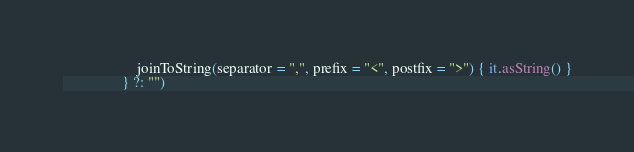<code> <loc_0><loc_0><loc_500><loc_500><_Kotlin_>                    joinToString(separator = ",", prefix = "<", postfix = ">") { it.asString() }
                } ?: "")</code> 